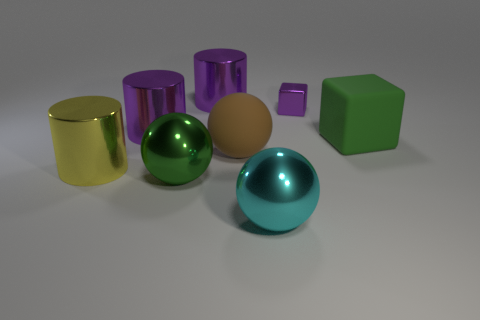Add 2 green blocks. How many objects exist? 10 Subtract all balls. How many objects are left? 5 Add 4 green matte objects. How many green matte objects are left? 5 Add 4 tiny purple shiny cubes. How many tiny purple shiny cubes exist? 5 Subtract 0 purple balls. How many objects are left? 8 Subtract all tiny purple metal objects. Subtract all cyan objects. How many objects are left? 6 